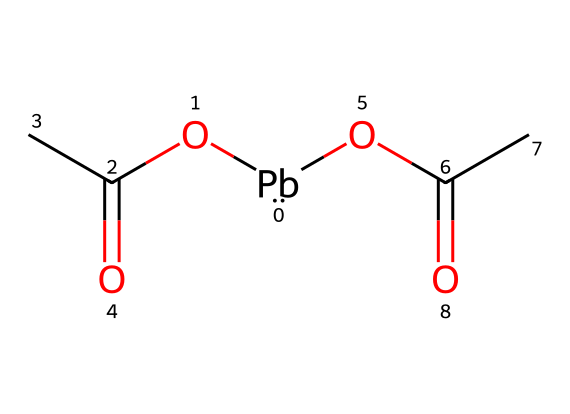What is the molecular formula of lead acetate? The molecular formula indicates the types and numbers of atoms present in a compound. From the SMILES representation [Pb](OC(C)=O)(OC(C)=O), we can identify the lead (Pb) atom and two acetate groups (C2H3O2). Therefore, the overall molecular formula is C4H6O4Pb.
Answer: C4H6O4Pb How many acetate groups are attached to the lead atom? By analyzing the structure denoted by the SMILES, we can see the lead (Pb) central atom is attached to two OC(C)=O groups. This indicates there are two acetate groups attached.
Answer: 2 What is the primary hazard associated with lead acetate? Lead acetate is primarily known for its toxicity and is a hazardous substance due to the presence of lead, which can cause severe health issues. Toxicity is a critical hazard associated with lead acetate.
Answer: toxicity How many total carbon atoms are present in lead acetate? The total number of carbon atoms can be determined by counting the carbons in each acetate group. Each acetate group (C(C)=O) contains two carbon atoms, and since there are two acetate groups, the total count is 4.
Answer: 4 What does the presence of lead in this chemical imply about its safety? The presence of lead in lead acetate suggests it is a heavy metal compound, typically posing significant health risks and potential for poisoning, which inherently makes it unsafe for general use.
Answer: unsafe What is the functional group of lead acetate? Analyzing the SMILES, the functional groups evident are the acetate (OC(C)=O). These groups define the primary reactivity of the compound.
Answer: acetate 